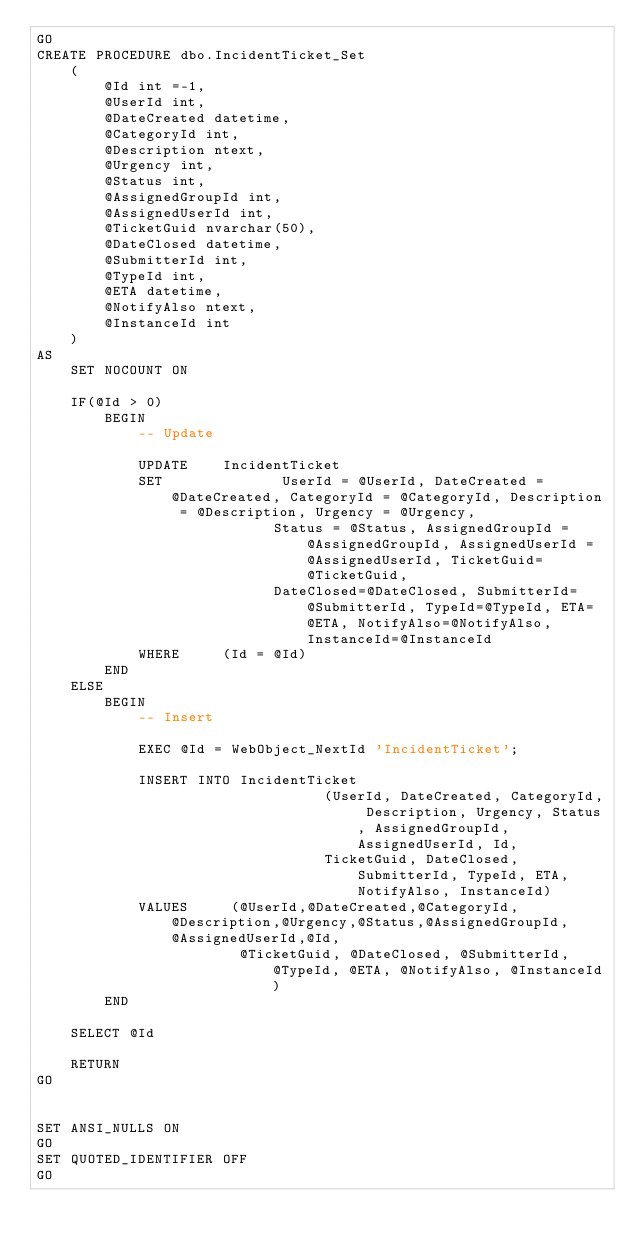Convert code to text. <code><loc_0><loc_0><loc_500><loc_500><_SQL_>GO
CREATE PROCEDURE dbo.IncidentTicket_Set
	(
		@Id int =-1,
		@UserId int,
		@DateCreated datetime,
		@CategoryId int,
		@Description ntext,
		@Urgency int,
		@Status int,
		@AssignedGroupId int,
		@AssignedUserId int,
		@TicketGuid nvarchar(50),
		@DateClosed datetime,
		@SubmitterId int,
		@TypeId int,
		@ETA datetime,
		@NotifyAlso ntext,
		@InstanceId int
	)
AS
	SET NOCOUNT ON

	IF(@Id > 0)
		BEGIN
			-- Update

			UPDATE    IncidentTicket
			SET              UserId = @UserId, DateCreated = @DateCreated, CategoryId = @CategoryId, Description = @Description, Urgency = @Urgency, 
							Status = @Status, AssignedGroupId = @AssignedGroupId, AssignedUserId = @AssignedUserId, TicketGuid=@TicketGuid,
							DateClosed=@DateClosed, SubmitterId=@SubmitterId, TypeId=@TypeId, ETA=@ETA, NotifyAlso=@NotifyAlso, InstanceId=@InstanceId
			WHERE     (Id = @Id)
		END
	ELSE
		BEGIN
			-- Insert

			EXEC @Id = WebObject_NextId 'IncidentTicket';

			INSERT INTO IncidentTicket
			                      (UserId, DateCreated, CategoryId, Description, Urgency, Status, AssignedGroupId, AssignedUserId, Id,
								  TicketGuid, DateClosed, SubmitterId, TypeId, ETA, NotifyAlso, InstanceId)
			VALUES     (@UserId,@DateCreated,@CategoryId,@Description,@Urgency,@Status,@AssignedGroupId,@AssignedUserId,@Id, 
						@TicketGuid, @DateClosed, @SubmitterId, @TypeId, @ETA, @NotifyAlso, @InstanceId)
		END

	SELECT @Id

	RETURN
GO


SET ANSI_NULLS ON
GO
SET QUOTED_IDENTIFIER OFF
GO

</code> 